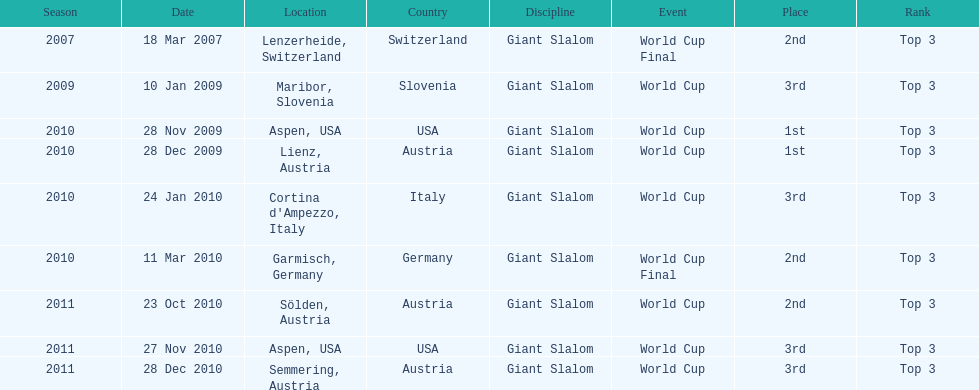Aspen and lienz in 2009 are the only races where this racer got what position? 1st. 